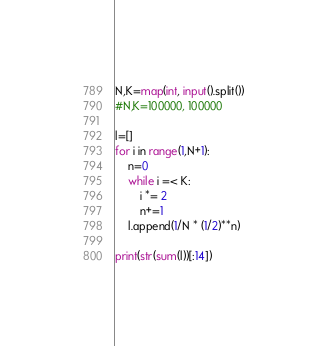<code> <loc_0><loc_0><loc_500><loc_500><_Python_>N,K=map(int, input().split())
#N,K=100000, 100000

l=[]
for i in range(1,N+1):
    n=0
    while i =< K:
        i *= 2
        n+=1
    l.append(1/N * (1/2)**n)

print(str(sum(l))[:14])
</code> 